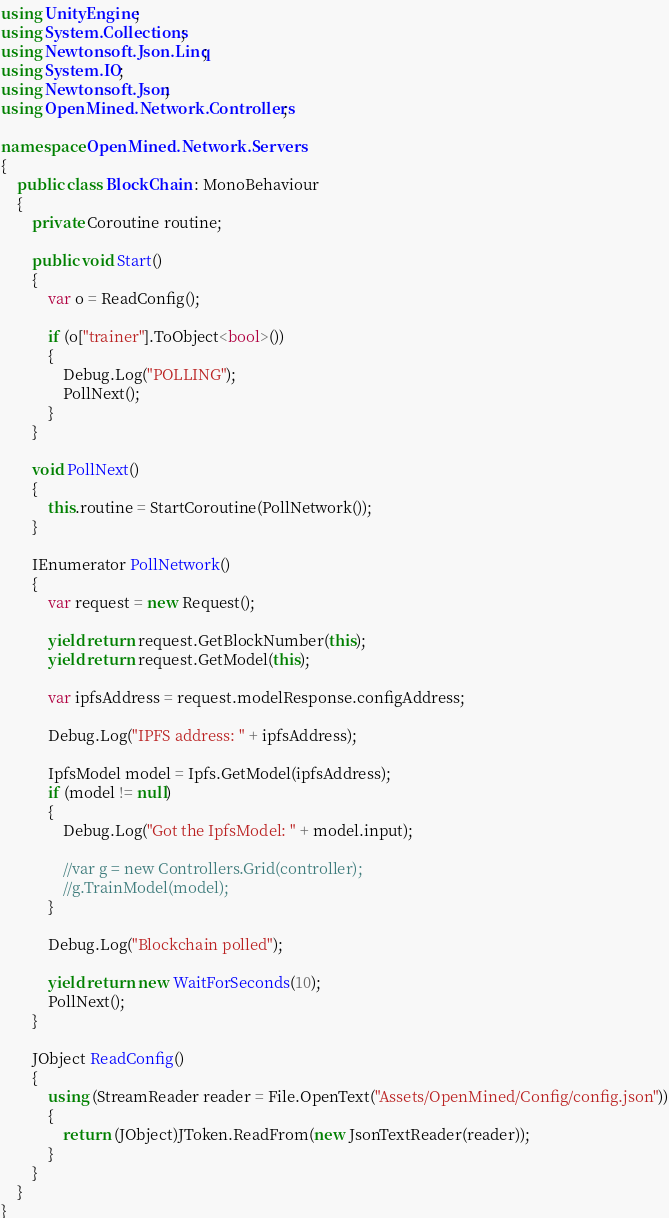<code> <loc_0><loc_0><loc_500><loc_500><_C#_>using UnityEngine;
using System.Collections;
using Newtonsoft.Json.Linq;
using System.IO;
using Newtonsoft.Json;
using OpenMined.Network.Controllers;

namespace OpenMined.Network.Servers
{
    public class BlockChain : MonoBehaviour
    {
        private Coroutine routine;
 
        public void Start()
        {
            var o = ReadConfig();

            if (o["trainer"].ToObject<bool>())
            {
                Debug.Log("POLLING");
                PollNext();
            }
        }

        void PollNext()
        {
            this.routine = StartCoroutine(PollNetwork());
        }

        IEnumerator PollNetwork()
        {
            var request = new Request();

            yield return request.GetBlockNumber(this);
            yield return request.GetModel(this);
            
            var ipfsAddress = request.modelResponse.configAddress;

            Debug.Log("IPFS address: " + ipfsAddress);

            IpfsModel model = Ipfs.GetModel(ipfsAddress);
            if (model != null)
            {
                Debug.Log("Got the IpfsModel: " + model.input);
                
                //var g = new Controllers.Grid(controller);
                //g.TrainModel(model);
            }

            Debug.Log("Blockchain polled");

            yield return new WaitForSeconds(10);
            PollNext();
        }
        
        JObject ReadConfig()
        {
            using (StreamReader reader = File.OpenText("Assets/OpenMined/Config/config.json"))
            {
                return (JObject)JToken.ReadFrom(new JsonTextReader(reader));
            }
        }
    }
}</code> 